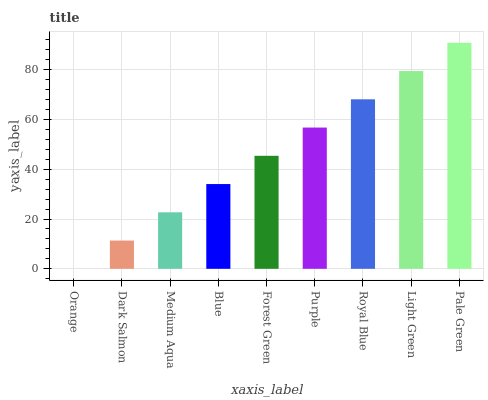Is Pale Green the maximum?
Answer yes or no. Yes. Is Dark Salmon the minimum?
Answer yes or no. No. Is Dark Salmon the maximum?
Answer yes or no. No. Is Dark Salmon greater than Orange?
Answer yes or no. Yes. Is Orange less than Dark Salmon?
Answer yes or no. Yes. Is Orange greater than Dark Salmon?
Answer yes or no. No. Is Dark Salmon less than Orange?
Answer yes or no. No. Is Forest Green the high median?
Answer yes or no. Yes. Is Forest Green the low median?
Answer yes or no. Yes. Is Blue the high median?
Answer yes or no. No. Is Royal Blue the low median?
Answer yes or no. No. 